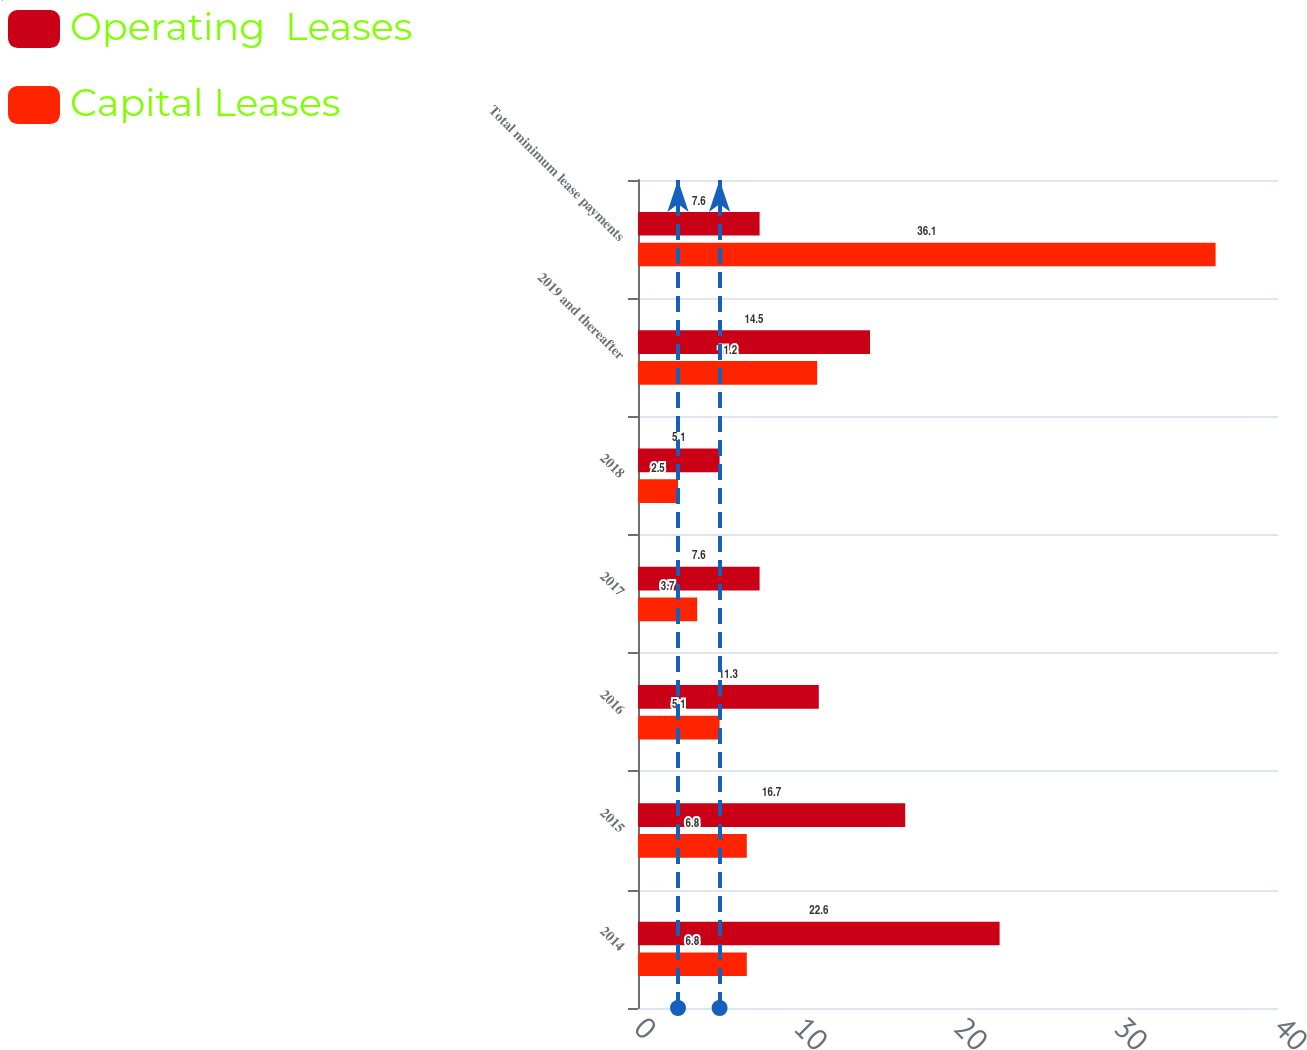<chart> <loc_0><loc_0><loc_500><loc_500><stacked_bar_chart><ecel><fcel>2014<fcel>2015<fcel>2016<fcel>2017<fcel>2018<fcel>2019 and thereafter<fcel>Total minimum lease payments<nl><fcel>Operating  Leases<fcel>22.6<fcel>16.7<fcel>11.3<fcel>7.6<fcel>5.1<fcel>14.5<fcel>7.6<nl><fcel>Capital Leases<fcel>6.8<fcel>6.8<fcel>5.1<fcel>3.7<fcel>2.5<fcel>11.2<fcel>36.1<nl></chart> 